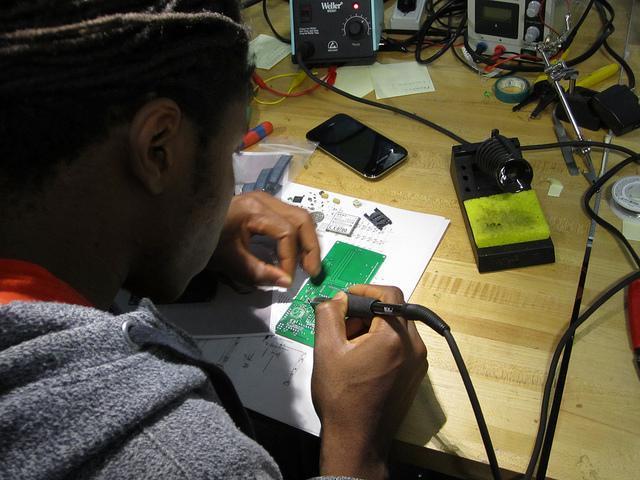How many people can be seen?
Give a very brief answer. 1. How many white plastic forks are there?
Give a very brief answer. 0. 